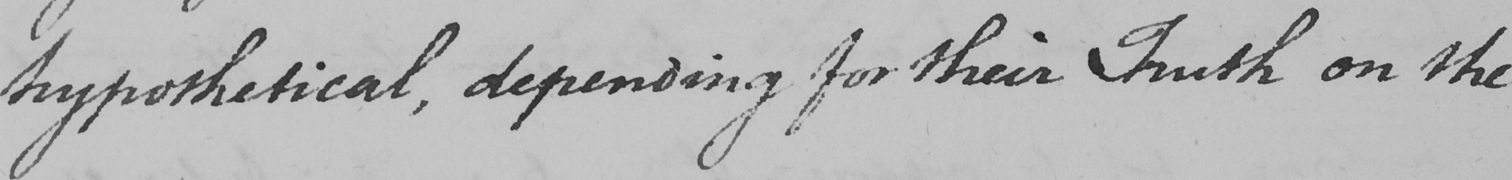What text is written in this handwritten line? hypothetical , depending for their Truth on the 